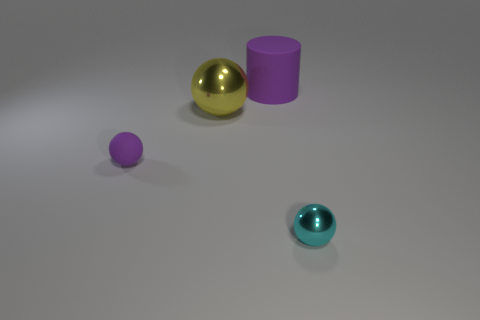The purple matte thing that is behind the big yellow sphere has what shape? cylinder 